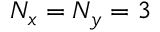Convert formula to latex. <formula><loc_0><loc_0><loc_500><loc_500>N _ { x } = N _ { y } = 3</formula> 